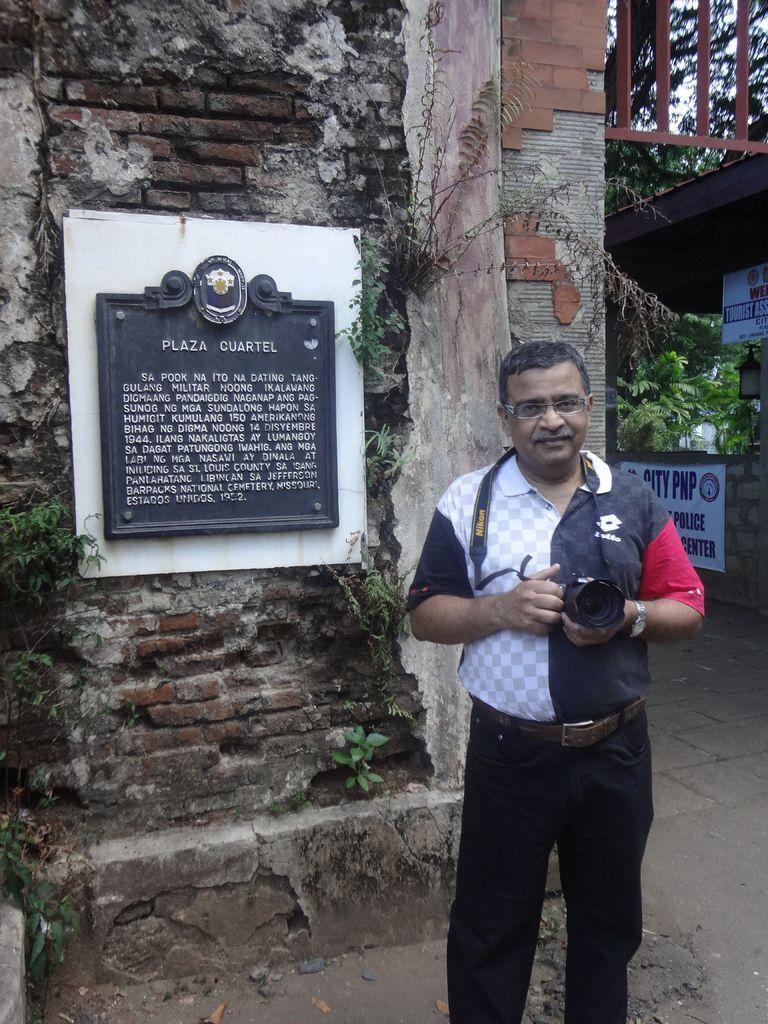Can you describe this image briefly? In this picture there is man standing holding camera in his hand. Beside him there is wall an don't there is board with text. There is banner on the wall to the right corner. There is railing, sky and tree in the image. 